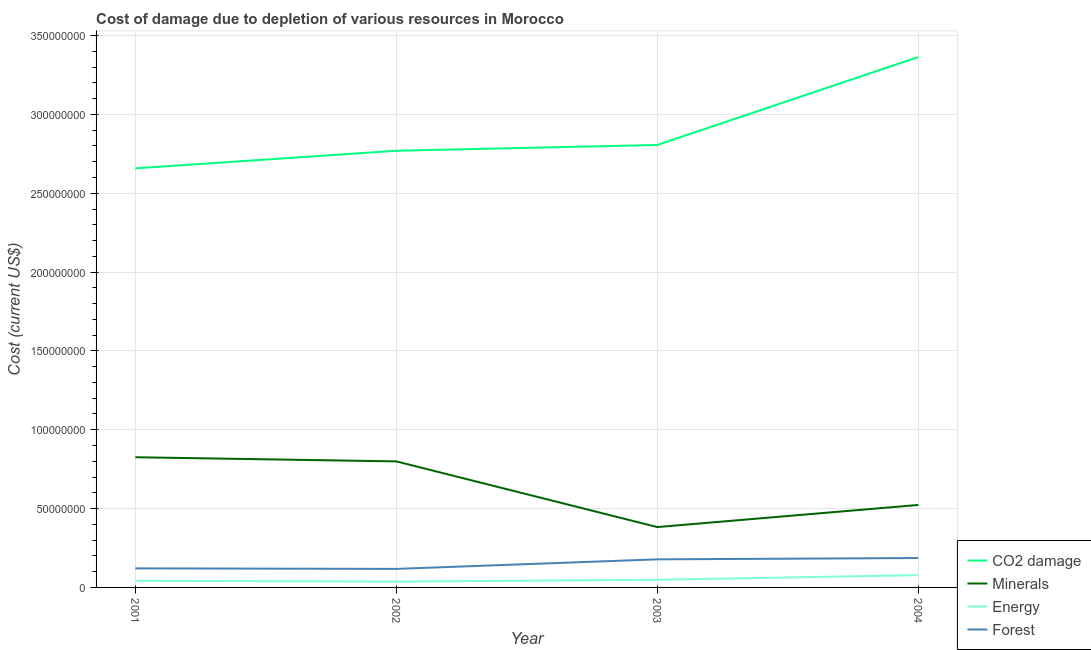How many different coloured lines are there?
Give a very brief answer. 4. Does the line corresponding to cost of damage due to depletion of minerals intersect with the line corresponding to cost of damage due to depletion of energy?
Make the answer very short. No. What is the cost of damage due to depletion of forests in 2003?
Provide a succinct answer. 1.78e+07. Across all years, what is the maximum cost of damage due to depletion of coal?
Ensure brevity in your answer.  3.36e+08. Across all years, what is the minimum cost of damage due to depletion of coal?
Offer a terse response. 2.66e+08. In which year was the cost of damage due to depletion of minerals maximum?
Ensure brevity in your answer.  2001. What is the total cost of damage due to depletion of coal in the graph?
Your answer should be very brief. 1.16e+09. What is the difference between the cost of damage due to depletion of coal in 2001 and that in 2003?
Your answer should be compact. -1.48e+07. What is the difference between the cost of damage due to depletion of coal in 2002 and the cost of damage due to depletion of minerals in 2001?
Ensure brevity in your answer.  1.94e+08. What is the average cost of damage due to depletion of energy per year?
Provide a succinct answer. 5.13e+06. In the year 2003, what is the difference between the cost of damage due to depletion of minerals and cost of damage due to depletion of energy?
Your answer should be very brief. 3.34e+07. What is the ratio of the cost of damage due to depletion of minerals in 2002 to that in 2004?
Provide a short and direct response. 1.53. What is the difference between the highest and the second highest cost of damage due to depletion of minerals?
Your response must be concise. 2.64e+06. What is the difference between the highest and the lowest cost of damage due to depletion of forests?
Ensure brevity in your answer.  6.89e+06. Is the cost of damage due to depletion of forests strictly greater than the cost of damage due to depletion of minerals over the years?
Ensure brevity in your answer.  No. Is the cost of damage due to depletion of energy strictly less than the cost of damage due to depletion of forests over the years?
Your response must be concise. Yes. Does the graph contain any zero values?
Provide a short and direct response. No. Does the graph contain grids?
Offer a very short reply. Yes. Where does the legend appear in the graph?
Make the answer very short. Bottom right. How are the legend labels stacked?
Give a very brief answer. Vertical. What is the title of the graph?
Provide a short and direct response. Cost of damage due to depletion of various resources in Morocco . Does "Greece" appear as one of the legend labels in the graph?
Your response must be concise. No. What is the label or title of the X-axis?
Ensure brevity in your answer.  Year. What is the label or title of the Y-axis?
Offer a very short reply. Cost (current US$). What is the Cost (current US$) in CO2 damage in 2001?
Your answer should be compact. 2.66e+08. What is the Cost (current US$) in Minerals in 2001?
Your response must be concise. 8.26e+07. What is the Cost (current US$) of Energy in 2001?
Your response must be concise. 4.21e+06. What is the Cost (current US$) in Forest in 2001?
Keep it short and to the point. 1.21e+07. What is the Cost (current US$) of CO2 damage in 2002?
Provide a succinct answer. 2.77e+08. What is the Cost (current US$) of Minerals in 2002?
Ensure brevity in your answer.  7.99e+07. What is the Cost (current US$) of Energy in 2002?
Offer a terse response. 3.70e+06. What is the Cost (current US$) in Forest in 2002?
Your response must be concise. 1.18e+07. What is the Cost (current US$) in CO2 damage in 2003?
Your response must be concise. 2.81e+08. What is the Cost (current US$) in Minerals in 2003?
Ensure brevity in your answer.  3.83e+07. What is the Cost (current US$) of Energy in 2003?
Make the answer very short. 4.85e+06. What is the Cost (current US$) of Forest in 2003?
Give a very brief answer. 1.78e+07. What is the Cost (current US$) of CO2 damage in 2004?
Provide a short and direct response. 3.36e+08. What is the Cost (current US$) in Minerals in 2004?
Your response must be concise. 5.23e+07. What is the Cost (current US$) in Energy in 2004?
Your answer should be compact. 7.78e+06. What is the Cost (current US$) in Forest in 2004?
Offer a very short reply. 1.86e+07. Across all years, what is the maximum Cost (current US$) of CO2 damage?
Offer a terse response. 3.36e+08. Across all years, what is the maximum Cost (current US$) of Minerals?
Keep it short and to the point. 8.26e+07. Across all years, what is the maximum Cost (current US$) in Energy?
Keep it short and to the point. 7.78e+06. Across all years, what is the maximum Cost (current US$) in Forest?
Offer a very short reply. 1.86e+07. Across all years, what is the minimum Cost (current US$) in CO2 damage?
Give a very brief answer. 2.66e+08. Across all years, what is the minimum Cost (current US$) in Minerals?
Provide a short and direct response. 3.83e+07. Across all years, what is the minimum Cost (current US$) in Energy?
Provide a succinct answer. 3.70e+06. Across all years, what is the minimum Cost (current US$) of Forest?
Make the answer very short. 1.18e+07. What is the total Cost (current US$) in CO2 damage in the graph?
Give a very brief answer. 1.16e+09. What is the total Cost (current US$) in Minerals in the graph?
Make the answer very short. 2.53e+08. What is the total Cost (current US$) in Energy in the graph?
Provide a succinct answer. 2.05e+07. What is the total Cost (current US$) in Forest in the graph?
Your response must be concise. 6.03e+07. What is the difference between the Cost (current US$) in CO2 damage in 2001 and that in 2002?
Your response must be concise. -1.12e+07. What is the difference between the Cost (current US$) of Minerals in 2001 and that in 2002?
Your answer should be very brief. 2.64e+06. What is the difference between the Cost (current US$) of Energy in 2001 and that in 2002?
Your response must be concise. 5.11e+05. What is the difference between the Cost (current US$) in Forest in 2001 and that in 2002?
Your answer should be compact. 3.32e+05. What is the difference between the Cost (current US$) of CO2 damage in 2001 and that in 2003?
Your response must be concise. -1.48e+07. What is the difference between the Cost (current US$) of Minerals in 2001 and that in 2003?
Ensure brevity in your answer.  4.43e+07. What is the difference between the Cost (current US$) in Energy in 2001 and that in 2003?
Keep it short and to the point. -6.39e+05. What is the difference between the Cost (current US$) of Forest in 2001 and that in 2003?
Offer a terse response. -5.73e+06. What is the difference between the Cost (current US$) in CO2 damage in 2001 and that in 2004?
Your answer should be compact. -7.06e+07. What is the difference between the Cost (current US$) of Minerals in 2001 and that in 2004?
Provide a succinct answer. 3.03e+07. What is the difference between the Cost (current US$) of Energy in 2001 and that in 2004?
Keep it short and to the point. -3.57e+06. What is the difference between the Cost (current US$) of Forest in 2001 and that in 2004?
Give a very brief answer. -6.56e+06. What is the difference between the Cost (current US$) of CO2 damage in 2002 and that in 2003?
Give a very brief answer. -3.66e+06. What is the difference between the Cost (current US$) of Minerals in 2002 and that in 2003?
Provide a short and direct response. 4.17e+07. What is the difference between the Cost (current US$) of Energy in 2002 and that in 2003?
Provide a succinct answer. -1.15e+06. What is the difference between the Cost (current US$) of Forest in 2002 and that in 2003?
Your answer should be very brief. -6.06e+06. What is the difference between the Cost (current US$) in CO2 damage in 2002 and that in 2004?
Offer a terse response. -5.94e+07. What is the difference between the Cost (current US$) of Minerals in 2002 and that in 2004?
Your response must be concise. 2.76e+07. What is the difference between the Cost (current US$) of Energy in 2002 and that in 2004?
Your response must be concise. -4.09e+06. What is the difference between the Cost (current US$) of Forest in 2002 and that in 2004?
Offer a very short reply. -6.89e+06. What is the difference between the Cost (current US$) of CO2 damage in 2003 and that in 2004?
Keep it short and to the point. -5.58e+07. What is the difference between the Cost (current US$) of Minerals in 2003 and that in 2004?
Make the answer very short. -1.40e+07. What is the difference between the Cost (current US$) of Energy in 2003 and that in 2004?
Your response must be concise. -2.94e+06. What is the difference between the Cost (current US$) of Forest in 2003 and that in 2004?
Your answer should be compact. -8.30e+05. What is the difference between the Cost (current US$) in CO2 damage in 2001 and the Cost (current US$) in Minerals in 2002?
Your answer should be compact. 1.86e+08. What is the difference between the Cost (current US$) in CO2 damage in 2001 and the Cost (current US$) in Energy in 2002?
Ensure brevity in your answer.  2.62e+08. What is the difference between the Cost (current US$) of CO2 damage in 2001 and the Cost (current US$) of Forest in 2002?
Offer a very short reply. 2.54e+08. What is the difference between the Cost (current US$) in Minerals in 2001 and the Cost (current US$) in Energy in 2002?
Your answer should be compact. 7.89e+07. What is the difference between the Cost (current US$) in Minerals in 2001 and the Cost (current US$) in Forest in 2002?
Make the answer very short. 7.08e+07. What is the difference between the Cost (current US$) of Energy in 2001 and the Cost (current US$) of Forest in 2002?
Provide a short and direct response. -7.54e+06. What is the difference between the Cost (current US$) of CO2 damage in 2001 and the Cost (current US$) of Minerals in 2003?
Make the answer very short. 2.28e+08. What is the difference between the Cost (current US$) in CO2 damage in 2001 and the Cost (current US$) in Energy in 2003?
Give a very brief answer. 2.61e+08. What is the difference between the Cost (current US$) in CO2 damage in 2001 and the Cost (current US$) in Forest in 2003?
Give a very brief answer. 2.48e+08. What is the difference between the Cost (current US$) in Minerals in 2001 and the Cost (current US$) in Energy in 2003?
Give a very brief answer. 7.77e+07. What is the difference between the Cost (current US$) of Minerals in 2001 and the Cost (current US$) of Forest in 2003?
Ensure brevity in your answer.  6.48e+07. What is the difference between the Cost (current US$) of Energy in 2001 and the Cost (current US$) of Forest in 2003?
Your answer should be very brief. -1.36e+07. What is the difference between the Cost (current US$) in CO2 damage in 2001 and the Cost (current US$) in Minerals in 2004?
Your response must be concise. 2.13e+08. What is the difference between the Cost (current US$) in CO2 damage in 2001 and the Cost (current US$) in Energy in 2004?
Your response must be concise. 2.58e+08. What is the difference between the Cost (current US$) in CO2 damage in 2001 and the Cost (current US$) in Forest in 2004?
Give a very brief answer. 2.47e+08. What is the difference between the Cost (current US$) in Minerals in 2001 and the Cost (current US$) in Energy in 2004?
Offer a terse response. 7.48e+07. What is the difference between the Cost (current US$) of Minerals in 2001 and the Cost (current US$) of Forest in 2004?
Your answer should be compact. 6.39e+07. What is the difference between the Cost (current US$) in Energy in 2001 and the Cost (current US$) in Forest in 2004?
Provide a succinct answer. -1.44e+07. What is the difference between the Cost (current US$) of CO2 damage in 2002 and the Cost (current US$) of Minerals in 2003?
Your response must be concise. 2.39e+08. What is the difference between the Cost (current US$) in CO2 damage in 2002 and the Cost (current US$) in Energy in 2003?
Provide a succinct answer. 2.72e+08. What is the difference between the Cost (current US$) of CO2 damage in 2002 and the Cost (current US$) of Forest in 2003?
Make the answer very short. 2.59e+08. What is the difference between the Cost (current US$) of Minerals in 2002 and the Cost (current US$) of Energy in 2003?
Make the answer very short. 7.51e+07. What is the difference between the Cost (current US$) in Minerals in 2002 and the Cost (current US$) in Forest in 2003?
Keep it short and to the point. 6.21e+07. What is the difference between the Cost (current US$) of Energy in 2002 and the Cost (current US$) of Forest in 2003?
Your answer should be very brief. -1.41e+07. What is the difference between the Cost (current US$) of CO2 damage in 2002 and the Cost (current US$) of Minerals in 2004?
Keep it short and to the point. 2.25e+08. What is the difference between the Cost (current US$) of CO2 damage in 2002 and the Cost (current US$) of Energy in 2004?
Ensure brevity in your answer.  2.69e+08. What is the difference between the Cost (current US$) of CO2 damage in 2002 and the Cost (current US$) of Forest in 2004?
Offer a terse response. 2.58e+08. What is the difference between the Cost (current US$) of Minerals in 2002 and the Cost (current US$) of Energy in 2004?
Give a very brief answer. 7.22e+07. What is the difference between the Cost (current US$) in Minerals in 2002 and the Cost (current US$) in Forest in 2004?
Your answer should be very brief. 6.13e+07. What is the difference between the Cost (current US$) in Energy in 2002 and the Cost (current US$) in Forest in 2004?
Provide a short and direct response. -1.49e+07. What is the difference between the Cost (current US$) in CO2 damage in 2003 and the Cost (current US$) in Minerals in 2004?
Offer a very short reply. 2.28e+08. What is the difference between the Cost (current US$) of CO2 damage in 2003 and the Cost (current US$) of Energy in 2004?
Your response must be concise. 2.73e+08. What is the difference between the Cost (current US$) of CO2 damage in 2003 and the Cost (current US$) of Forest in 2004?
Ensure brevity in your answer.  2.62e+08. What is the difference between the Cost (current US$) in Minerals in 2003 and the Cost (current US$) in Energy in 2004?
Your answer should be very brief. 3.05e+07. What is the difference between the Cost (current US$) of Minerals in 2003 and the Cost (current US$) of Forest in 2004?
Your answer should be compact. 1.96e+07. What is the difference between the Cost (current US$) in Energy in 2003 and the Cost (current US$) in Forest in 2004?
Provide a short and direct response. -1.38e+07. What is the average Cost (current US$) of CO2 damage per year?
Your answer should be compact. 2.90e+08. What is the average Cost (current US$) in Minerals per year?
Make the answer very short. 6.33e+07. What is the average Cost (current US$) in Energy per year?
Make the answer very short. 5.13e+06. What is the average Cost (current US$) in Forest per year?
Your answer should be compact. 1.51e+07. In the year 2001, what is the difference between the Cost (current US$) of CO2 damage and Cost (current US$) of Minerals?
Your response must be concise. 1.83e+08. In the year 2001, what is the difference between the Cost (current US$) in CO2 damage and Cost (current US$) in Energy?
Give a very brief answer. 2.62e+08. In the year 2001, what is the difference between the Cost (current US$) in CO2 damage and Cost (current US$) in Forest?
Give a very brief answer. 2.54e+08. In the year 2001, what is the difference between the Cost (current US$) in Minerals and Cost (current US$) in Energy?
Your response must be concise. 7.84e+07. In the year 2001, what is the difference between the Cost (current US$) of Minerals and Cost (current US$) of Forest?
Provide a succinct answer. 7.05e+07. In the year 2001, what is the difference between the Cost (current US$) in Energy and Cost (current US$) in Forest?
Provide a succinct answer. -7.87e+06. In the year 2002, what is the difference between the Cost (current US$) of CO2 damage and Cost (current US$) of Minerals?
Your answer should be very brief. 1.97e+08. In the year 2002, what is the difference between the Cost (current US$) in CO2 damage and Cost (current US$) in Energy?
Make the answer very short. 2.73e+08. In the year 2002, what is the difference between the Cost (current US$) of CO2 damage and Cost (current US$) of Forest?
Keep it short and to the point. 2.65e+08. In the year 2002, what is the difference between the Cost (current US$) of Minerals and Cost (current US$) of Energy?
Provide a short and direct response. 7.62e+07. In the year 2002, what is the difference between the Cost (current US$) in Minerals and Cost (current US$) in Forest?
Your answer should be very brief. 6.82e+07. In the year 2002, what is the difference between the Cost (current US$) in Energy and Cost (current US$) in Forest?
Make the answer very short. -8.05e+06. In the year 2003, what is the difference between the Cost (current US$) of CO2 damage and Cost (current US$) of Minerals?
Ensure brevity in your answer.  2.42e+08. In the year 2003, what is the difference between the Cost (current US$) of CO2 damage and Cost (current US$) of Energy?
Provide a succinct answer. 2.76e+08. In the year 2003, what is the difference between the Cost (current US$) of CO2 damage and Cost (current US$) of Forest?
Keep it short and to the point. 2.63e+08. In the year 2003, what is the difference between the Cost (current US$) of Minerals and Cost (current US$) of Energy?
Provide a short and direct response. 3.34e+07. In the year 2003, what is the difference between the Cost (current US$) of Minerals and Cost (current US$) of Forest?
Your answer should be compact. 2.05e+07. In the year 2003, what is the difference between the Cost (current US$) in Energy and Cost (current US$) in Forest?
Your answer should be compact. -1.30e+07. In the year 2004, what is the difference between the Cost (current US$) in CO2 damage and Cost (current US$) in Minerals?
Keep it short and to the point. 2.84e+08. In the year 2004, what is the difference between the Cost (current US$) in CO2 damage and Cost (current US$) in Energy?
Keep it short and to the point. 3.29e+08. In the year 2004, what is the difference between the Cost (current US$) in CO2 damage and Cost (current US$) in Forest?
Offer a very short reply. 3.18e+08. In the year 2004, what is the difference between the Cost (current US$) of Minerals and Cost (current US$) of Energy?
Provide a succinct answer. 4.45e+07. In the year 2004, what is the difference between the Cost (current US$) of Minerals and Cost (current US$) of Forest?
Offer a terse response. 3.37e+07. In the year 2004, what is the difference between the Cost (current US$) in Energy and Cost (current US$) in Forest?
Ensure brevity in your answer.  -1.09e+07. What is the ratio of the Cost (current US$) of CO2 damage in 2001 to that in 2002?
Your response must be concise. 0.96. What is the ratio of the Cost (current US$) in Minerals in 2001 to that in 2002?
Your response must be concise. 1.03. What is the ratio of the Cost (current US$) of Energy in 2001 to that in 2002?
Provide a short and direct response. 1.14. What is the ratio of the Cost (current US$) of Forest in 2001 to that in 2002?
Ensure brevity in your answer.  1.03. What is the ratio of the Cost (current US$) of CO2 damage in 2001 to that in 2003?
Keep it short and to the point. 0.95. What is the ratio of the Cost (current US$) of Minerals in 2001 to that in 2003?
Your answer should be very brief. 2.16. What is the ratio of the Cost (current US$) in Energy in 2001 to that in 2003?
Your response must be concise. 0.87. What is the ratio of the Cost (current US$) of Forest in 2001 to that in 2003?
Your answer should be compact. 0.68. What is the ratio of the Cost (current US$) of CO2 damage in 2001 to that in 2004?
Your answer should be compact. 0.79. What is the ratio of the Cost (current US$) in Minerals in 2001 to that in 2004?
Keep it short and to the point. 1.58. What is the ratio of the Cost (current US$) of Energy in 2001 to that in 2004?
Offer a very short reply. 0.54. What is the ratio of the Cost (current US$) in Forest in 2001 to that in 2004?
Offer a very short reply. 0.65. What is the ratio of the Cost (current US$) in CO2 damage in 2002 to that in 2003?
Your answer should be compact. 0.99. What is the ratio of the Cost (current US$) in Minerals in 2002 to that in 2003?
Provide a succinct answer. 2.09. What is the ratio of the Cost (current US$) of Energy in 2002 to that in 2003?
Your response must be concise. 0.76. What is the ratio of the Cost (current US$) of Forest in 2002 to that in 2003?
Provide a succinct answer. 0.66. What is the ratio of the Cost (current US$) in CO2 damage in 2002 to that in 2004?
Your answer should be very brief. 0.82. What is the ratio of the Cost (current US$) of Minerals in 2002 to that in 2004?
Offer a terse response. 1.53. What is the ratio of the Cost (current US$) in Energy in 2002 to that in 2004?
Offer a very short reply. 0.48. What is the ratio of the Cost (current US$) in Forest in 2002 to that in 2004?
Make the answer very short. 0.63. What is the ratio of the Cost (current US$) in CO2 damage in 2003 to that in 2004?
Your answer should be compact. 0.83. What is the ratio of the Cost (current US$) of Minerals in 2003 to that in 2004?
Make the answer very short. 0.73. What is the ratio of the Cost (current US$) of Energy in 2003 to that in 2004?
Keep it short and to the point. 0.62. What is the ratio of the Cost (current US$) in Forest in 2003 to that in 2004?
Provide a succinct answer. 0.96. What is the difference between the highest and the second highest Cost (current US$) in CO2 damage?
Offer a terse response. 5.58e+07. What is the difference between the highest and the second highest Cost (current US$) in Minerals?
Your response must be concise. 2.64e+06. What is the difference between the highest and the second highest Cost (current US$) in Energy?
Provide a short and direct response. 2.94e+06. What is the difference between the highest and the second highest Cost (current US$) in Forest?
Ensure brevity in your answer.  8.30e+05. What is the difference between the highest and the lowest Cost (current US$) in CO2 damage?
Provide a short and direct response. 7.06e+07. What is the difference between the highest and the lowest Cost (current US$) of Minerals?
Ensure brevity in your answer.  4.43e+07. What is the difference between the highest and the lowest Cost (current US$) of Energy?
Ensure brevity in your answer.  4.09e+06. What is the difference between the highest and the lowest Cost (current US$) in Forest?
Offer a terse response. 6.89e+06. 